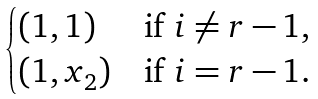<formula> <loc_0><loc_0><loc_500><loc_500>\begin{cases} ( 1 , 1 ) & \text {if } i \ne r - 1 , \\ ( 1 , x _ { 2 } ) & \text {if } i = r - 1 . \end{cases}</formula> 